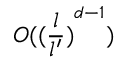<formula> <loc_0><loc_0><loc_500><loc_500>O ( { ( \frac { l } { l ^ { \prime } } ) } ^ { d - 1 } )</formula> 